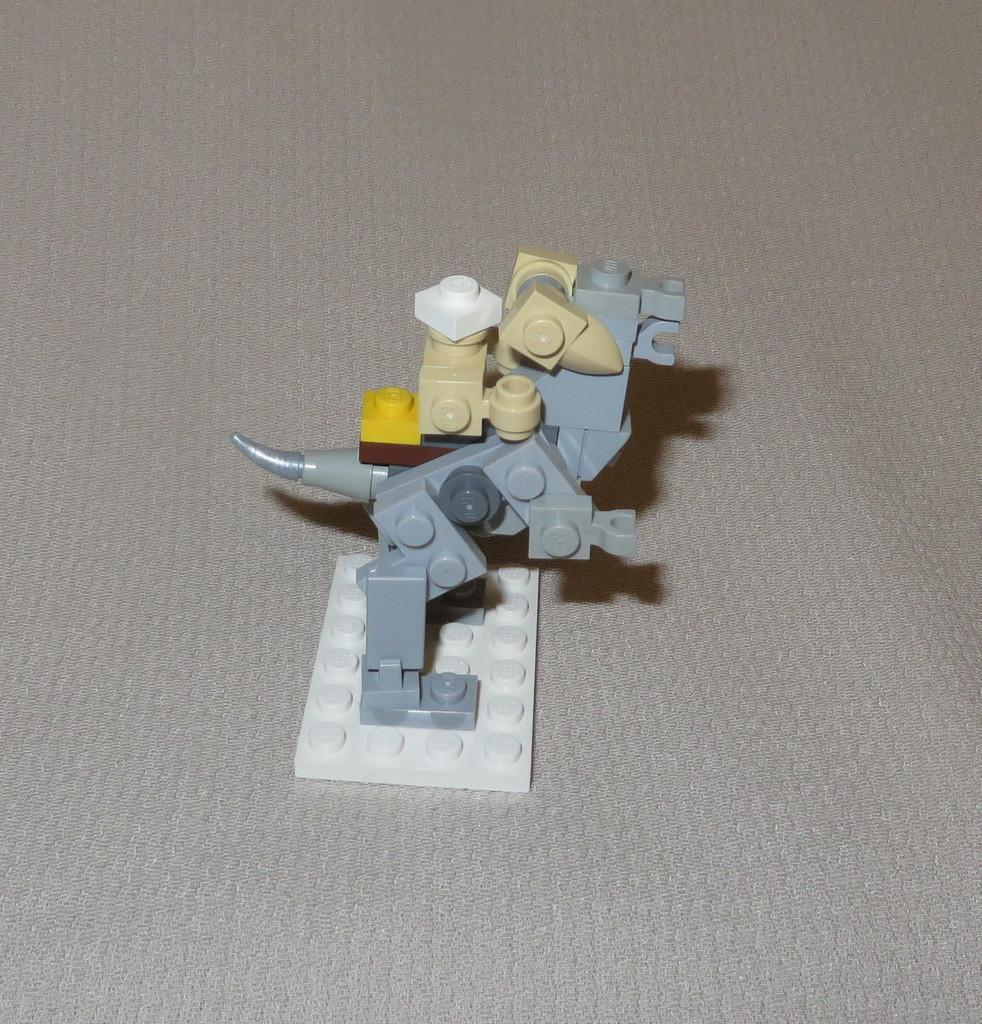What type of object is the main subject of the image? The main subject of the image is an animal made of building blocks. What is the animal placed on in the image? The animal is placed on a grey surface. Can you see a goldfish swimming in the image? No, there is no goldfish present in the image. Is there a monkey holding an umbrella in the image? No, there is no monkey or umbrella present in the image. 